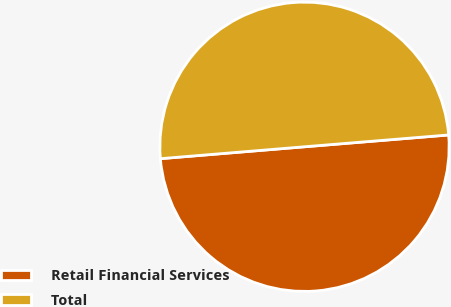Convert chart. <chart><loc_0><loc_0><loc_500><loc_500><pie_chart><fcel>Retail Financial Services<fcel>Total<nl><fcel>49.99%<fcel>50.01%<nl></chart> 